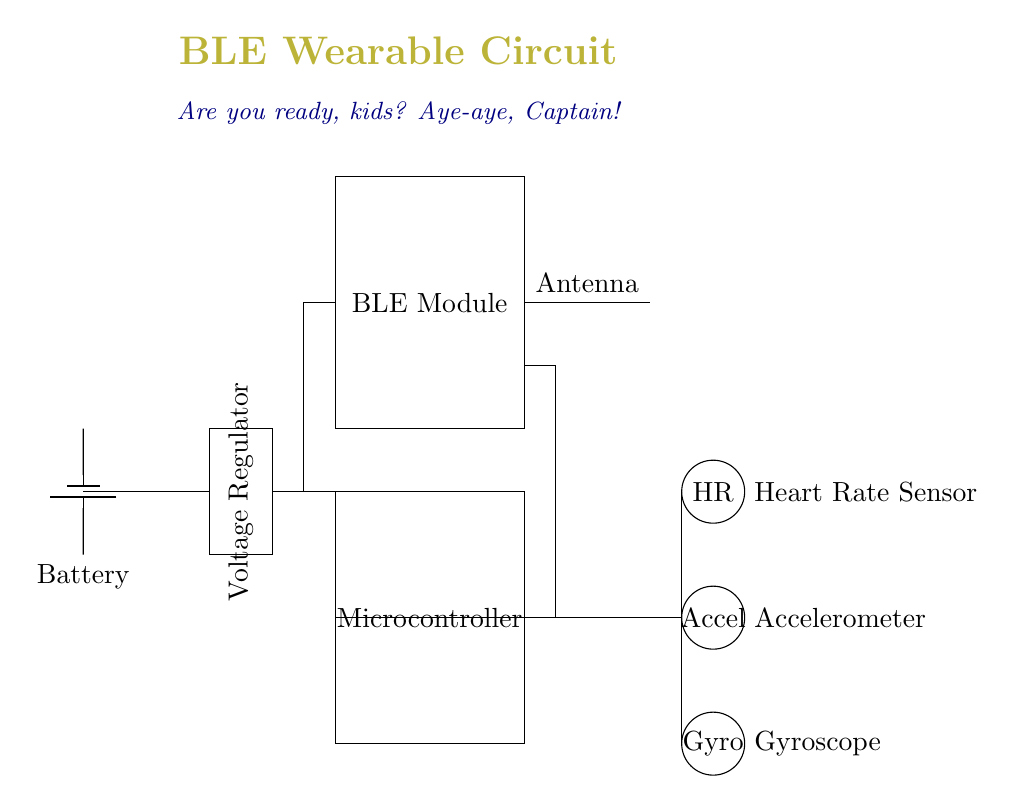What is the main function of the BLE module? The BLE module enables wireless communication with wearable devices, allowing them to transmit health and activity metrics.
Answer: Wireless communication What component regulates voltage in the circuit? The component responsible for voltage regulation is explicitly labeled as the Voltage Regulator, which ensures that the microcontroller and other components receive the required voltage level.
Answer: Voltage Regulator How many sensors are connected to the microcontroller? The circuit diagram shows three sensors connected to the microcontroller: Heart Rate, Accelerometer, and Gyroscope.
Answer: Three What type of power source is used in this circuit? The circuit uses a battery as the power source, as indicated by the battery symbol. This supplies the necessary power for the entire circuit.
Answer: Battery Which sensor is used to measure heart rate? The Heart Rate sensor is explicitly labeled on the diagram, positioned on the right side, indicating it is responsible for measuring heart rate.
Answer: Heart Rate Sensor What is the purpose of the antenna in this circuit? The antenna allows the BLE module to transmit and receive signals wirelessly, facilitating communication with other devices.
Answer: Wireless transmission What is the series of connections leading from the BLE module to the sensors? The connections from the BLE module run from the module downwards, branching out to the three sensors: Heart Rate, Accelerometer, and Gyroscope. This indicates a direct communication path between the module and the sensors.
Answer: Direct connection 